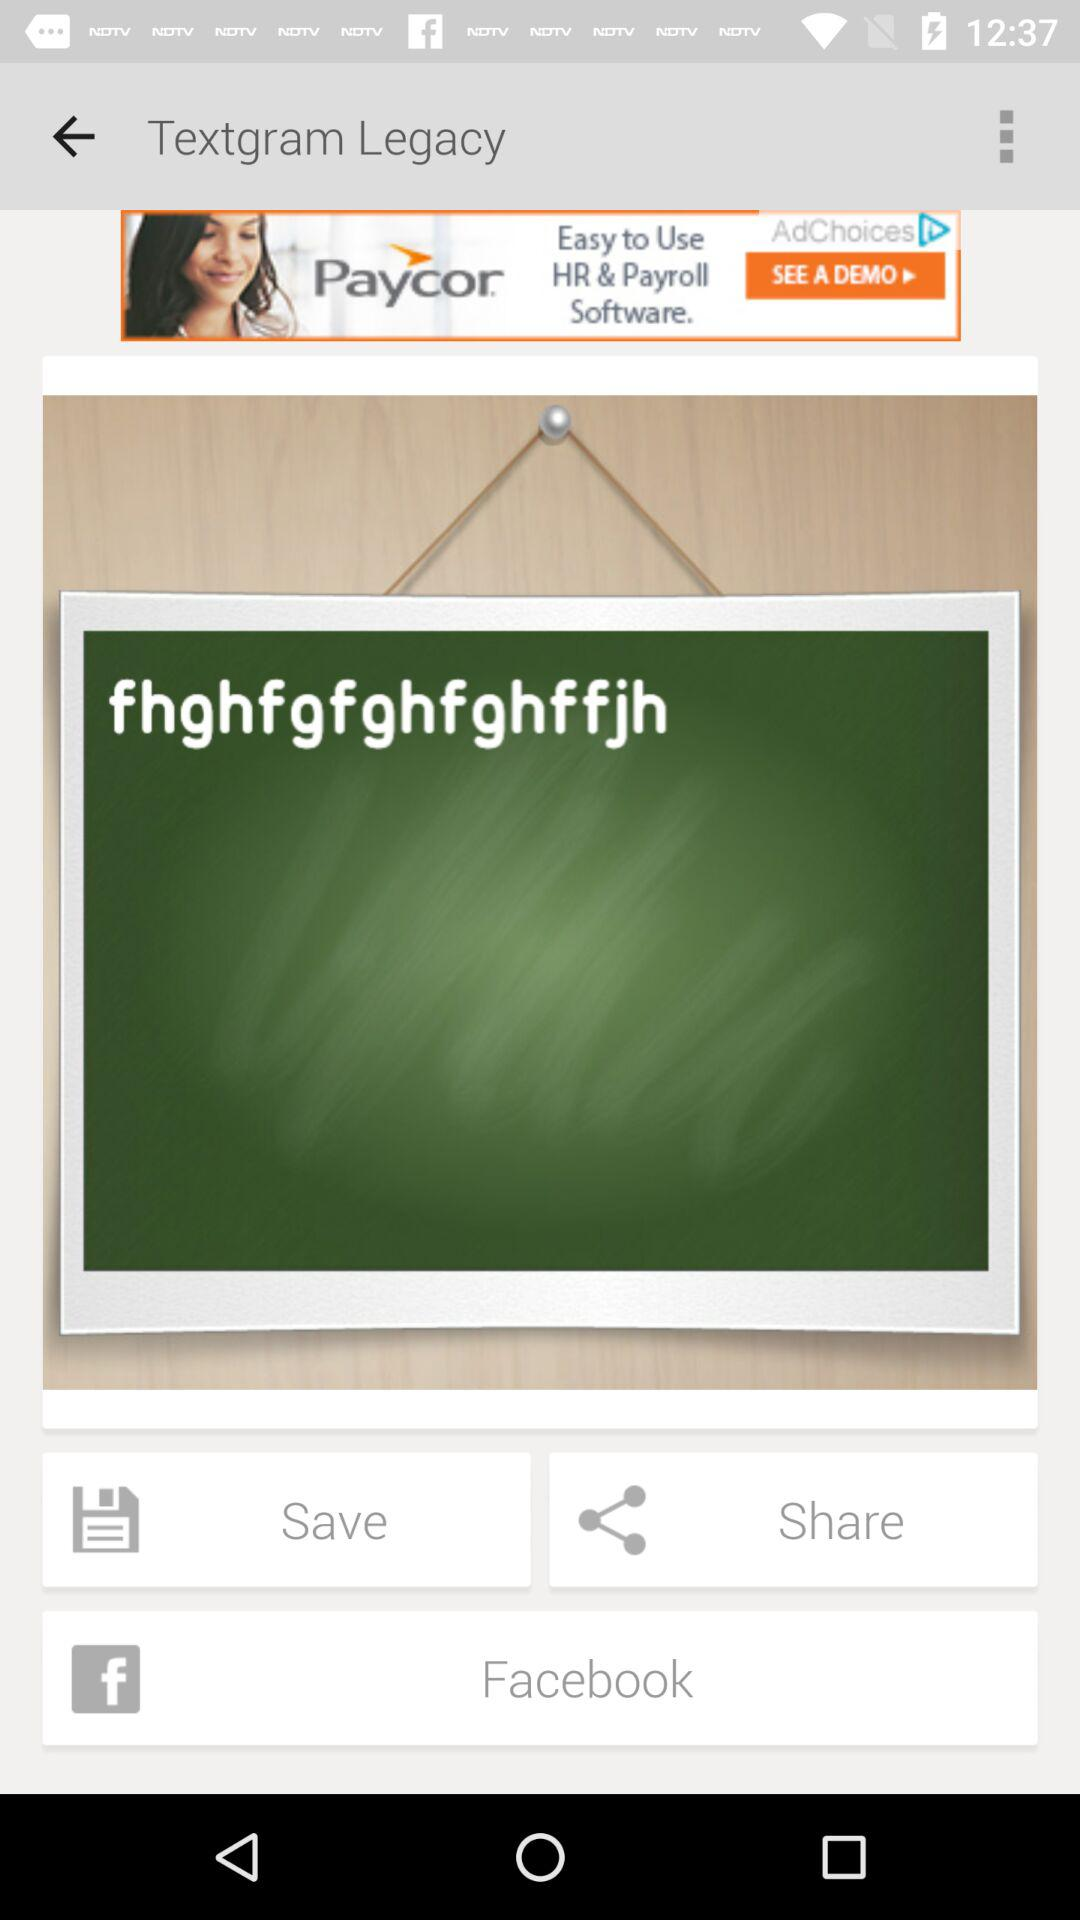What is the name of the application? The name of the application is "Textgram Legacy". 